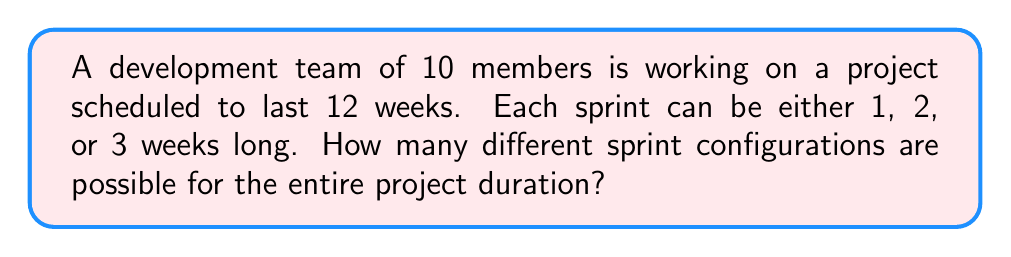Solve this math problem. Let's approach this step-by-step:

1) First, we need to understand that this is a partition problem. We're partitioning 12 weeks into parts of 1, 2, or 3 weeks.

2) Let's define variables:
   $x_1$ = number of 1-week sprints
   $x_2$ = number of 2-week sprints
   $x_3$ = number of 3-week sprints

3) We can form an equation:
   $x_1 + 2x_2 + 3x_3 = 12$

4) We need to find all non-negative integer solutions to this equation.

5) Let's list out all possibilities:
   (12, 0, 0), (10, 1, 0), (8, 2, 0), (6, 3, 0), (4, 4, 0), (2, 5, 0), (0, 6, 0)
   (9, 0, 1), (7, 1, 1), (5, 2, 1), (3, 3, 1), (1, 4, 1)
   (6, 0, 2), (4, 1, 2), (2, 2, 2), (0, 3, 2)
   (3, 0, 3), (1, 1, 3)
   (0, 0, 4)

6) Counting these up, we find there are 19 different possible configurations.

7) Note that the team size (10) doesn't affect the number of configurations in this case. It would be relevant if we were assigning tasks within sprints, but for just determining sprint durations, it doesn't play a role.
Answer: 19 